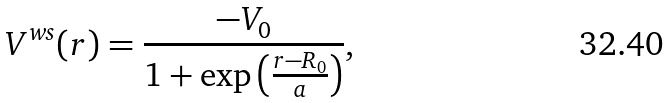Convert formula to latex. <formula><loc_0><loc_0><loc_500><loc_500>V ^ { w s } ( r ) = \frac { - V _ { 0 } } { 1 + \exp \left ( \frac { r - R _ { 0 } } { a } \right ) } ,</formula> 